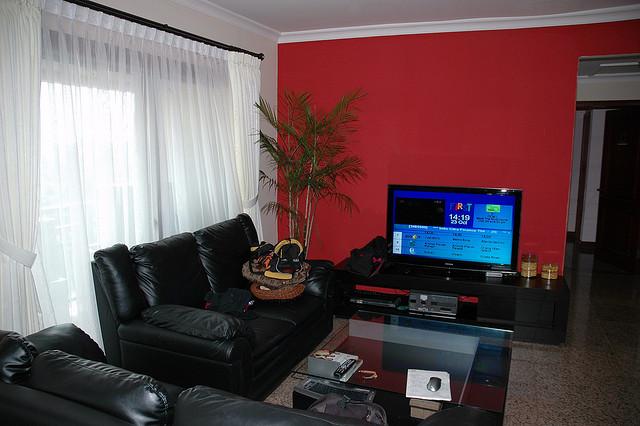What is the sofa leg made from?
Keep it brief. Wood. Are the couches going to watch some TV?
Be succinct. No. Are these curtains similar in color to burlap?
Give a very brief answer. No. What time is it in the photo?
Concise answer only. 14:19. What room of the house is this?
Short answer required. Living room. Is this a toilet room?
Concise answer only. No. What colors are the walls?
Write a very short answer. Red. What room is this?
Write a very short answer. Living room. What color are the drapes?
Short answer required. White. Is the coffee table made of glass?
Keep it brief. Yes. What electronic device is on the table?
Give a very brief answer. Mouse. How many monitors are there?
Answer briefly. 1. Is there natural light?
Short answer required. Yes. What type of pattern is the couch made of?
Write a very short answer. Leather. What color is the wall?
Answer briefly. Red. What electronic device is on the coffee table?
Short answer required. Mouse. What is next to the television?
Concise answer only. Tree. 